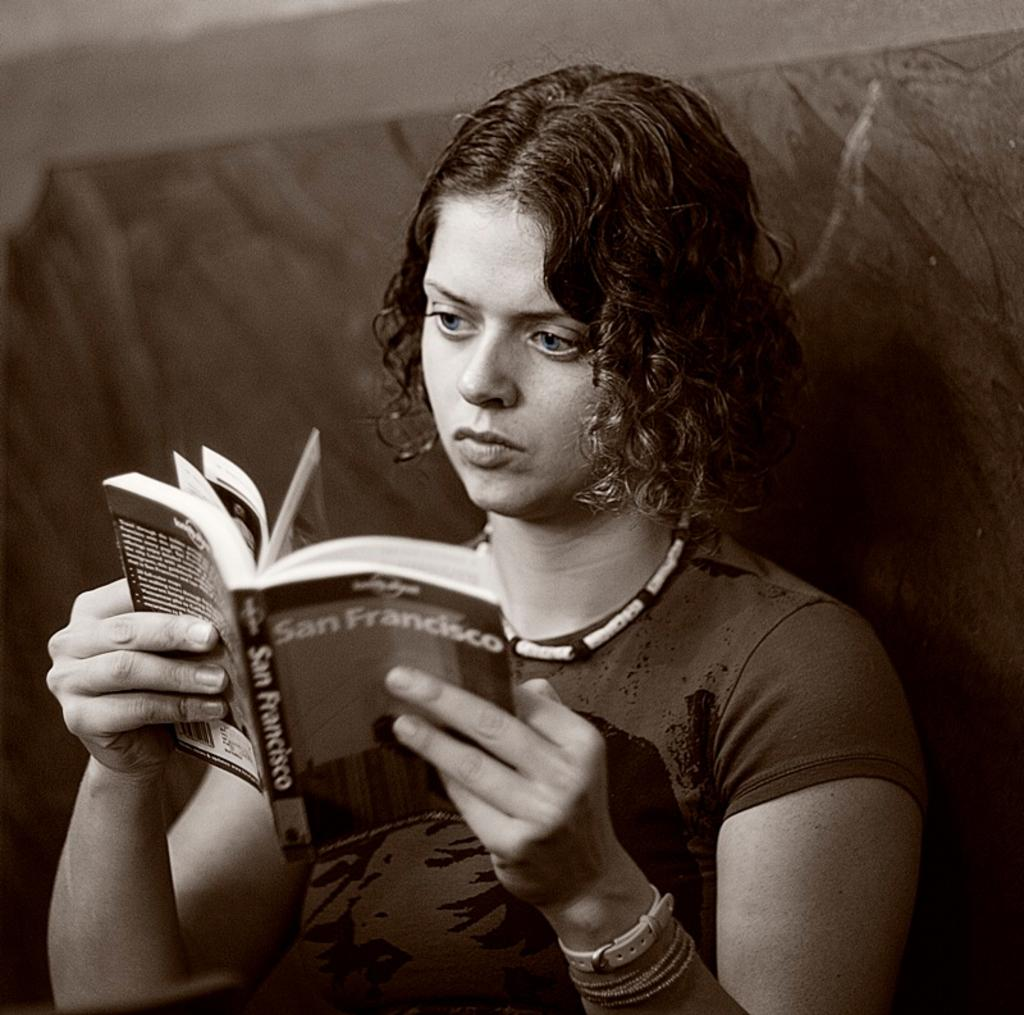Who is the main subject in the image? There is a lady in the image. What is the lady doing in the image? The lady is sitting in the image. What is the lady holding in the image? The lady is holding a book in the image. What can be seen in the background of the image? There is a wall in the background of the image. Can you describe the detail of the earthquake in the image? There is no earthquake present in the image. What is the end result of the lady's actions in the image? The image does not show the end result of the lady's actions, as it only captures a moment in time. 